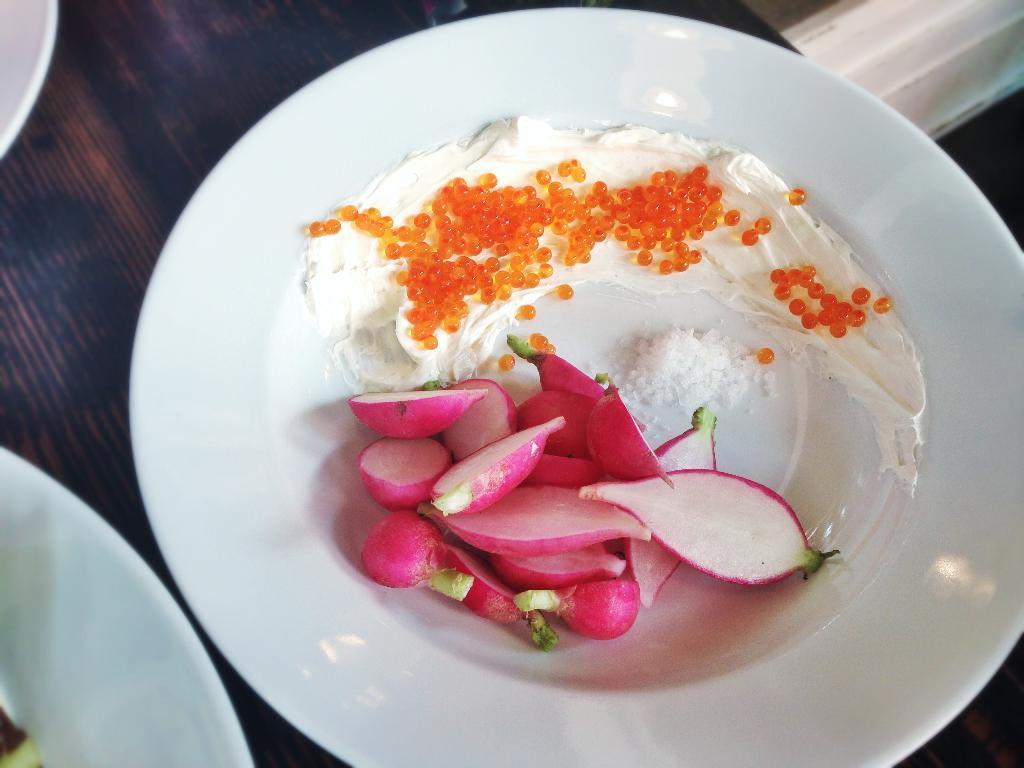Please provide a concise description of this image. In this picture there is a plate in the center of the image, which contains food items in it and there are other planets in the top left and right side of the image. 